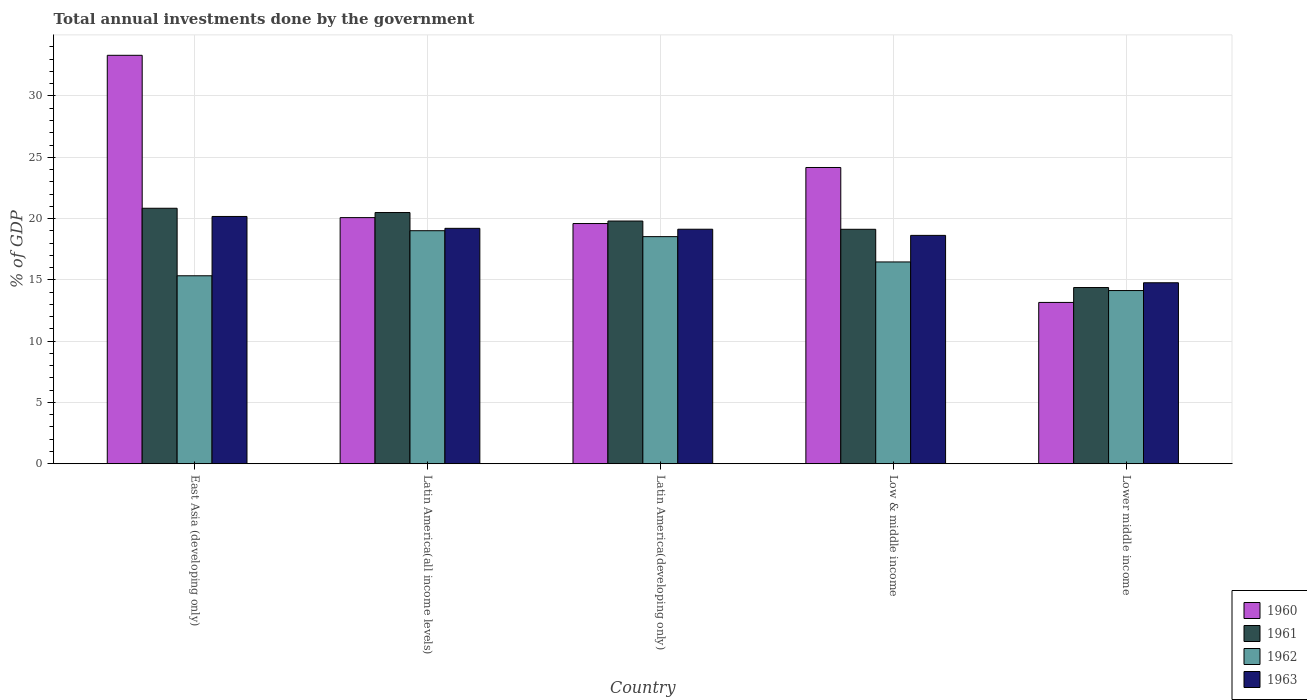Are the number of bars per tick equal to the number of legend labels?
Offer a very short reply. Yes. Are the number of bars on each tick of the X-axis equal?
Your response must be concise. Yes. How many bars are there on the 5th tick from the right?
Offer a terse response. 4. What is the label of the 2nd group of bars from the left?
Offer a terse response. Latin America(all income levels). What is the total annual investments done by the government in 1962 in Low & middle income?
Your answer should be compact. 16.46. Across all countries, what is the maximum total annual investments done by the government in 1961?
Make the answer very short. 20.84. Across all countries, what is the minimum total annual investments done by the government in 1962?
Give a very brief answer. 14.13. In which country was the total annual investments done by the government in 1963 maximum?
Provide a succinct answer. East Asia (developing only). In which country was the total annual investments done by the government in 1962 minimum?
Your answer should be very brief. Lower middle income. What is the total total annual investments done by the government in 1960 in the graph?
Your response must be concise. 110.32. What is the difference between the total annual investments done by the government in 1962 in Latin America(all income levels) and that in Latin America(developing only)?
Give a very brief answer. 0.48. What is the difference between the total annual investments done by the government in 1962 in Low & middle income and the total annual investments done by the government in 1963 in East Asia (developing only)?
Your answer should be compact. -3.71. What is the average total annual investments done by the government in 1963 per country?
Offer a terse response. 18.38. What is the difference between the total annual investments done by the government of/in 1962 and total annual investments done by the government of/in 1961 in Lower middle income?
Provide a succinct answer. -0.25. What is the ratio of the total annual investments done by the government in 1961 in Latin America(all income levels) to that in Lower middle income?
Keep it short and to the point. 1.43. Is the total annual investments done by the government in 1961 in East Asia (developing only) less than that in Latin America(all income levels)?
Provide a succinct answer. No. Is the difference between the total annual investments done by the government in 1962 in Latin America(developing only) and Lower middle income greater than the difference between the total annual investments done by the government in 1961 in Latin America(developing only) and Lower middle income?
Your answer should be compact. No. What is the difference between the highest and the second highest total annual investments done by the government in 1962?
Provide a short and direct response. -2.07. What is the difference between the highest and the lowest total annual investments done by the government in 1963?
Your answer should be very brief. 5.41. Is the sum of the total annual investments done by the government in 1961 in East Asia (developing only) and Lower middle income greater than the maximum total annual investments done by the government in 1960 across all countries?
Provide a succinct answer. Yes. Is it the case that in every country, the sum of the total annual investments done by the government in 1960 and total annual investments done by the government in 1961 is greater than the sum of total annual investments done by the government in 1963 and total annual investments done by the government in 1962?
Provide a short and direct response. No. What does the 4th bar from the left in Latin America(all income levels) represents?
Ensure brevity in your answer.  1963. How many bars are there?
Give a very brief answer. 20. Are all the bars in the graph horizontal?
Offer a very short reply. No. How many countries are there in the graph?
Offer a terse response. 5. Are the values on the major ticks of Y-axis written in scientific E-notation?
Ensure brevity in your answer.  No. What is the title of the graph?
Make the answer very short. Total annual investments done by the government. What is the label or title of the X-axis?
Offer a very short reply. Country. What is the label or title of the Y-axis?
Your answer should be very brief. % of GDP. What is the % of GDP of 1960 in East Asia (developing only)?
Offer a terse response. 33.32. What is the % of GDP in 1961 in East Asia (developing only)?
Your answer should be compact. 20.84. What is the % of GDP in 1962 in East Asia (developing only)?
Your answer should be compact. 15.33. What is the % of GDP of 1963 in East Asia (developing only)?
Keep it short and to the point. 20.17. What is the % of GDP in 1960 in Latin America(all income levels)?
Your response must be concise. 20.08. What is the % of GDP in 1961 in Latin America(all income levels)?
Give a very brief answer. 20.49. What is the % of GDP of 1962 in Latin America(all income levels)?
Provide a succinct answer. 19.01. What is the % of GDP of 1963 in Latin America(all income levels)?
Provide a short and direct response. 19.2. What is the % of GDP of 1960 in Latin America(developing only)?
Provide a succinct answer. 19.6. What is the % of GDP in 1961 in Latin America(developing only)?
Provide a succinct answer. 19.8. What is the % of GDP in 1962 in Latin America(developing only)?
Offer a very short reply. 18.53. What is the % of GDP in 1963 in Latin America(developing only)?
Your answer should be compact. 19.13. What is the % of GDP in 1960 in Low & middle income?
Offer a terse response. 24.17. What is the % of GDP of 1961 in Low & middle income?
Make the answer very short. 19.13. What is the % of GDP of 1962 in Low & middle income?
Provide a short and direct response. 16.46. What is the % of GDP in 1963 in Low & middle income?
Your answer should be very brief. 18.63. What is the % of GDP in 1960 in Lower middle income?
Offer a terse response. 13.16. What is the % of GDP of 1961 in Lower middle income?
Your response must be concise. 14.37. What is the % of GDP in 1962 in Lower middle income?
Provide a short and direct response. 14.13. What is the % of GDP of 1963 in Lower middle income?
Your answer should be very brief. 14.76. Across all countries, what is the maximum % of GDP in 1960?
Make the answer very short. 33.32. Across all countries, what is the maximum % of GDP of 1961?
Offer a terse response. 20.84. Across all countries, what is the maximum % of GDP of 1962?
Offer a very short reply. 19.01. Across all countries, what is the maximum % of GDP in 1963?
Ensure brevity in your answer.  20.17. Across all countries, what is the minimum % of GDP in 1960?
Provide a succinct answer. 13.16. Across all countries, what is the minimum % of GDP in 1961?
Keep it short and to the point. 14.37. Across all countries, what is the minimum % of GDP of 1962?
Give a very brief answer. 14.13. Across all countries, what is the minimum % of GDP in 1963?
Ensure brevity in your answer.  14.76. What is the total % of GDP of 1960 in the graph?
Your answer should be compact. 110.32. What is the total % of GDP of 1961 in the graph?
Ensure brevity in your answer.  94.63. What is the total % of GDP of 1962 in the graph?
Offer a terse response. 83.46. What is the total % of GDP in 1963 in the graph?
Ensure brevity in your answer.  91.9. What is the difference between the % of GDP in 1960 in East Asia (developing only) and that in Latin America(all income levels)?
Make the answer very short. 13.24. What is the difference between the % of GDP in 1961 in East Asia (developing only) and that in Latin America(all income levels)?
Keep it short and to the point. 0.35. What is the difference between the % of GDP of 1962 in East Asia (developing only) and that in Latin America(all income levels)?
Provide a short and direct response. -3.68. What is the difference between the % of GDP in 1963 in East Asia (developing only) and that in Latin America(all income levels)?
Your response must be concise. 0.97. What is the difference between the % of GDP of 1960 in East Asia (developing only) and that in Latin America(developing only)?
Ensure brevity in your answer.  13.72. What is the difference between the % of GDP of 1961 in East Asia (developing only) and that in Latin America(developing only)?
Keep it short and to the point. 1.04. What is the difference between the % of GDP of 1962 in East Asia (developing only) and that in Latin America(developing only)?
Make the answer very short. -3.19. What is the difference between the % of GDP in 1963 in East Asia (developing only) and that in Latin America(developing only)?
Ensure brevity in your answer.  1.04. What is the difference between the % of GDP of 1960 in East Asia (developing only) and that in Low & middle income?
Provide a succinct answer. 9.15. What is the difference between the % of GDP of 1961 in East Asia (developing only) and that in Low & middle income?
Your answer should be very brief. 1.72. What is the difference between the % of GDP of 1962 in East Asia (developing only) and that in Low & middle income?
Your response must be concise. -1.13. What is the difference between the % of GDP in 1963 in East Asia (developing only) and that in Low & middle income?
Provide a short and direct response. 1.54. What is the difference between the % of GDP of 1960 in East Asia (developing only) and that in Lower middle income?
Your response must be concise. 20.16. What is the difference between the % of GDP in 1961 in East Asia (developing only) and that in Lower middle income?
Offer a terse response. 6.47. What is the difference between the % of GDP in 1962 in East Asia (developing only) and that in Lower middle income?
Ensure brevity in your answer.  1.21. What is the difference between the % of GDP of 1963 in East Asia (developing only) and that in Lower middle income?
Make the answer very short. 5.41. What is the difference between the % of GDP in 1960 in Latin America(all income levels) and that in Latin America(developing only)?
Your answer should be compact. 0.48. What is the difference between the % of GDP in 1961 in Latin America(all income levels) and that in Latin America(developing only)?
Offer a terse response. 0.69. What is the difference between the % of GDP of 1962 in Latin America(all income levels) and that in Latin America(developing only)?
Keep it short and to the point. 0.48. What is the difference between the % of GDP of 1963 in Latin America(all income levels) and that in Latin America(developing only)?
Your answer should be compact. 0.07. What is the difference between the % of GDP in 1960 in Latin America(all income levels) and that in Low & middle income?
Offer a terse response. -4.09. What is the difference between the % of GDP of 1961 in Latin America(all income levels) and that in Low & middle income?
Make the answer very short. 1.37. What is the difference between the % of GDP of 1962 in Latin America(all income levels) and that in Low & middle income?
Make the answer very short. 2.55. What is the difference between the % of GDP of 1963 in Latin America(all income levels) and that in Low & middle income?
Your response must be concise. 0.57. What is the difference between the % of GDP in 1960 in Latin America(all income levels) and that in Lower middle income?
Make the answer very short. 6.92. What is the difference between the % of GDP in 1961 in Latin America(all income levels) and that in Lower middle income?
Offer a terse response. 6.12. What is the difference between the % of GDP in 1962 in Latin America(all income levels) and that in Lower middle income?
Your response must be concise. 4.88. What is the difference between the % of GDP in 1963 in Latin America(all income levels) and that in Lower middle income?
Your answer should be compact. 4.44. What is the difference between the % of GDP of 1960 in Latin America(developing only) and that in Low & middle income?
Keep it short and to the point. -4.57. What is the difference between the % of GDP of 1961 in Latin America(developing only) and that in Low & middle income?
Keep it short and to the point. 0.67. What is the difference between the % of GDP in 1962 in Latin America(developing only) and that in Low & middle income?
Make the answer very short. 2.07. What is the difference between the % of GDP of 1963 in Latin America(developing only) and that in Low & middle income?
Offer a terse response. 0.5. What is the difference between the % of GDP of 1960 in Latin America(developing only) and that in Lower middle income?
Keep it short and to the point. 6.44. What is the difference between the % of GDP of 1961 in Latin America(developing only) and that in Lower middle income?
Provide a short and direct response. 5.42. What is the difference between the % of GDP in 1962 in Latin America(developing only) and that in Lower middle income?
Your response must be concise. 4.4. What is the difference between the % of GDP in 1963 in Latin America(developing only) and that in Lower middle income?
Your answer should be very brief. 4.37. What is the difference between the % of GDP in 1960 in Low & middle income and that in Lower middle income?
Your answer should be very brief. 11.01. What is the difference between the % of GDP in 1961 in Low & middle income and that in Lower middle income?
Your answer should be very brief. 4.75. What is the difference between the % of GDP of 1962 in Low & middle income and that in Lower middle income?
Your answer should be very brief. 2.33. What is the difference between the % of GDP of 1963 in Low & middle income and that in Lower middle income?
Your response must be concise. 3.87. What is the difference between the % of GDP of 1960 in East Asia (developing only) and the % of GDP of 1961 in Latin America(all income levels)?
Provide a short and direct response. 12.83. What is the difference between the % of GDP of 1960 in East Asia (developing only) and the % of GDP of 1962 in Latin America(all income levels)?
Provide a succinct answer. 14.31. What is the difference between the % of GDP of 1960 in East Asia (developing only) and the % of GDP of 1963 in Latin America(all income levels)?
Ensure brevity in your answer.  14.12. What is the difference between the % of GDP in 1961 in East Asia (developing only) and the % of GDP in 1962 in Latin America(all income levels)?
Offer a very short reply. 1.83. What is the difference between the % of GDP of 1961 in East Asia (developing only) and the % of GDP of 1963 in Latin America(all income levels)?
Ensure brevity in your answer.  1.64. What is the difference between the % of GDP of 1962 in East Asia (developing only) and the % of GDP of 1963 in Latin America(all income levels)?
Your answer should be very brief. -3.87. What is the difference between the % of GDP of 1960 in East Asia (developing only) and the % of GDP of 1961 in Latin America(developing only)?
Offer a terse response. 13.52. What is the difference between the % of GDP in 1960 in East Asia (developing only) and the % of GDP in 1962 in Latin America(developing only)?
Make the answer very short. 14.79. What is the difference between the % of GDP in 1960 in East Asia (developing only) and the % of GDP in 1963 in Latin America(developing only)?
Provide a succinct answer. 14.19. What is the difference between the % of GDP of 1961 in East Asia (developing only) and the % of GDP of 1962 in Latin America(developing only)?
Give a very brief answer. 2.31. What is the difference between the % of GDP of 1961 in East Asia (developing only) and the % of GDP of 1963 in Latin America(developing only)?
Your response must be concise. 1.71. What is the difference between the % of GDP in 1962 in East Asia (developing only) and the % of GDP in 1963 in Latin America(developing only)?
Your answer should be very brief. -3.8. What is the difference between the % of GDP of 1960 in East Asia (developing only) and the % of GDP of 1961 in Low & middle income?
Make the answer very short. 14.19. What is the difference between the % of GDP in 1960 in East Asia (developing only) and the % of GDP in 1962 in Low & middle income?
Offer a terse response. 16.86. What is the difference between the % of GDP in 1960 in East Asia (developing only) and the % of GDP in 1963 in Low & middle income?
Offer a terse response. 14.69. What is the difference between the % of GDP in 1961 in East Asia (developing only) and the % of GDP in 1962 in Low & middle income?
Offer a terse response. 4.38. What is the difference between the % of GDP of 1961 in East Asia (developing only) and the % of GDP of 1963 in Low & middle income?
Your answer should be compact. 2.21. What is the difference between the % of GDP in 1962 in East Asia (developing only) and the % of GDP in 1963 in Low & middle income?
Your response must be concise. -3.3. What is the difference between the % of GDP of 1960 in East Asia (developing only) and the % of GDP of 1961 in Lower middle income?
Your answer should be compact. 18.95. What is the difference between the % of GDP of 1960 in East Asia (developing only) and the % of GDP of 1962 in Lower middle income?
Your answer should be very brief. 19.19. What is the difference between the % of GDP in 1960 in East Asia (developing only) and the % of GDP in 1963 in Lower middle income?
Provide a succinct answer. 18.56. What is the difference between the % of GDP in 1961 in East Asia (developing only) and the % of GDP in 1962 in Lower middle income?
Your answer should be compact. 6.71. What is the difference between the % of GDP in 1961 in East Asia (developing only) and the % of GDP in 1963 in Lower middle income?
Keep it short and to the point. 6.08. What is the difference between the % of GDP of 1962 in East Asia (developing only) and the % of GDP of 1963 in Lower middle income?
Provide a short and direct response. 0.57. What is the difference between the % of GDP of 1960 in Latin America(all income levels) and the % of GDP of 1961 in Latin America(developing only)?
Your answer should be very brief. 0.28. What is the difference between the % of GDP of 1960 in Latin America(all income levels) and the % of GDP of 1962 in Latin America(developing only)?
Your response must be concise. 1.55. What is the difference between the % of GDP in 1960 in Latin America(all income levels) and the % of GDP in 1963 in Latin America(developing only)?
Your answer should be very brief. 0.95. What is the difference between the % of GDP of 1961 in Latin America(all income levels) and the % of GDP of 1962 in Latin America(developing only)?
Provide a succinct answer. 1.97. What is the difference between the % of GDP in 1961 in Latin America(all income levels) and the % of GDP in 1963 in Latin America(developing only)?
Your response must be concise. 1.36. What is the difference between the % of GDP in 1962 in Latin America(all income levels) and the % of GDP in 1963 in Latin America(developing only)?
Provide a succinct answer. -0.12. What is the difference between the % of GDP of 1960 in Latin America(all income levels) and the % of GDP of 1961 in Low & middle income?
Your answer should be compact. 0.95. What is the difference between the % of GDP in 1960 in Latin America(all income levels) and the % of GDP in 1962 in Low & middle income?
Keep it short and to the point. 3.62. What is the difference between the % of GDP of 1960 in Latin America(all income levels) and the % of GDP of 1963 in Low & middle income?
Your answer should be very brief. 1.45. What is the difference between the % of GDP in 1961 in Latin America(all income levels) and the % of GDP in 1962 in Low & middle income?
Your response must be concise. 4.03. What is the difference between the % of GDP in 1961 in Latin America(all income levels) and the % of GDP in 1963 in Low & middle income?
Provide a short and direct response. 1.86. What is the difference between the % of GDP in 1962 in Latin America(all income levels) and the % of GDP in 1963 in Low & middle income?
Provide a succinct answer. 0.38. What is the difference between the % of GDP in 1960 in Latin America(all income levels) and the % of GDP in 1961 in Lower middle income?
Provide a succinct answer. 5.7. What is the difference between the % of GDP of 1960 in Latin America(all income levels) and the % of GDP of 1962 in Lower middle income?
Your answer should be compact. 5.95. What is the difference between the % of GDP in 1960 in Latin America(all income levels) and the % of GDP in 1963 in Lower middle income?
Your answer should be compact. 5.31. What is the difference between the % of GDP of 1961 in Latin America(all income levels) and the % of GDP of 1962 in Lower middle income?
Your response must be concise. 6.36. What is the difference between the % of GDP of 1961 in Latin America(all income levels) and the % of GDP of 1963 in Lower middle income?
Make the answer very short. 5.73. What is the difference between the % of GDP in 1962 in Latin America(all income levels) and the % of GDP in 1963 in Lower middle income?
Give a very brief answer. 4.25. What is the difference between the % of GDP in 1960 in Latin America(developing only) and the % of GDP in 1961 in Low & middle income?
Give a very brief answer. 0.47. What is the difference between the % of GDP in 1960 in Latin America(developing only) and the % of GDP in 1962 in Low & middle income?
Offer a very short reply. 3.13. What is the difference between the % of GDP in 1960 in Latin America(developing only) and the % of GDP in 1963 in Low & middle income?
Ensure brevity in your answer.  0.97. What is the difference between the % of GDP in 1961 in Latin America(developing only) and the % of GDP in 1962 in Low & middle income?
Provide a succinct answer. 3.34. What is the difference between the % of GDP of 1961 in Latin America(developing only) and the % of GDP of 1963 in Low & middle income?
Offer a very short reply. 1.17. What is the difference between the % of GDP in 1962 in Latin America(developing only) and the % of GDP in 1963 in Low & middle income?
Your answer should be very brief. -0.1. What is the difference between the % of GDP in 1960 in Latin America(developing only) and the % of GDP in 1961 in Lower middle income?
Make the answer very short. 5.22. What is the difference between the % of GDP in 1960 in Latin America(developing only) and the % of GDP in 1962 in Lower middle income?
Offer a terse response. 5.47. What is the difference between the % of GDP in 1960 in Latin America(developing only) and the % of GDP in 1963 in Lower middle income?
Your answer should be compact. 4.83. What is the difference between the % of GDP in 1961 in Latin America(developing only) and the % of GDP in 1962 in Lower middle income?
Your response must be concise. 5.67. What is the difference between the % of GDP in 1961 in Latin America(developing only) and the % of GDP in 1963 in Lower middle income?
Ensure brevity in your answer.  5.04. What is the difference between the % of GDP of 1962 in Latin America(developing only) and the % of GDP of 1963 in Lower middle income?
Give a very brief answer. 3.76. What is the difference between the % of GDP in 1960 in Low & middle income and the % of GDP in 1961 in Lower middle income?
Provide a short and direct response. 9.79. What is the difference between the % of GDP of 1960 in Low & middle income and the % of GDP of 1962 in Lower middle income?
Your answer should be very brief. 10.04. What is the difference between the % of GDP of 1960 in Low & middle income and the % of GDP of 1963 in Lower middle income?
Your answer should be compact. 9.4. What is the difference between the % of GDP in 1961 in Low & middle income and the % of GDP in 1962 in Lower middle income?
Offer a very short reply. 5. What is the difference between the % of GDP of 1961 in Low & middle income and the % of GDP of 1963 in Lower middle income?
Offer a terse response. 4.36. What is the difference between the % of GDP of 1962 in Low & middle income and the % of GDP of 1963 in Lower middle income?
Provide a succinct answer. 1.7. What is the average % of GDP of 1960 per country?
Give a very brief answer. 22.06. What is the average % of GDP in 1961 per country?
Provide a succinct answer. 18.93. What is the average % of GDP in 1962 per country?
Offer a very short reply. 16.69. What is the average % of GDP in 1963 per country?
Your answer should be very brief. 18.38. What is the difference between the % of GDP of 1960 and % of GDP of 1961 in East Asia (developing only)?
Provide a short and direct response. 12.48. What is the difference between the % of GDP in 1960 and % of GDP in 1962 in East Asia (developing only)?
Give a very brief answer. 17.99. What is the difference between the % of GDP in 1960 and % of GDP in 1963 in East Asia (developing only)?
Offer a very short reply. 13.15. What is the difference between the % of GDP in 1961 and % of GDP in 1962 in East Asia (developing only)?
Your response must be concise. 5.51. What is the difference between the % of GDP of 1961 and % of GDP of 1963 in East Asia (developing only)?
Ensure brevity in your answer.  0.67. What is the difference between the % of GDP in 1962 and % of GDP in 1963 in East Asia (developing only)?
Your response must be concise. -4.84. What is the difference between the % of GDP in 1960 and % of GDP in 1961 in Latin America(all income levels)?
Provide a succinct answer. -0.41. What is the difference between the % of GDP in 1960 and % of GDP in 1962 in Latin America(all income levels)?
Make the answer very short. 1.07. What is the difference between the % of GDP of 1960 and % of GDP of 1963 in Latin America(all income levels)?
Provide a succinct answer. 0.87. What is the difference between the % of GDP of 1961 and % of GDP of 1962 in Latin America(all income levels)?
Your response must be concise. 1.48. What is the difference between the % of GDP of 1961 and % of GDP of 1963 in Latin America(all income levels)?
Provide a short and direct response. 1.29. What is the difference between the % of GDP of 1962 and % of GDP of 1963 in Latin America(all income levels)?
Keep it short and to the point. -0.19. What is the difference between the % of GDP of 1960 and % of GDP of 1961 in Latin America(developing only)?
Ensure brevity in your answer.  -0.2. What is the difference between the % of GDP in 1960 and % of GDP in 1962 in Latin America(developing only)?
Your answer should be compact. 1.07. What is the difference between the % of GDP in 1960 and % of GDP in 1963 in Latin America(developing only)?
Give a very brief answer. 0.46. What is the difference between the % of GDP in 1961 and % of GDP in 1962 in Latin America(developing only)?
Provide a succinct answer. 1.27. What is the difference between the % of GDP of 1961 and % of GDP of 1963 in Latin America(developing only)?
Give a very brief answer. 0.67. What is the difference between the % of GDP in 1962 and % of GDP in 1963 in Latin America(developing only)?
Your answer should be compact. -0.6. What is the difference between the % of GDP of 1960 and % of GDP of 1961 in Low & middle income?
Keep it short and to the point. 5.04. What is the difference between the % of GDP in 1960 and % of GDP in 1962 in Low & middle income?
Your answer should be compact. 7.71. What is the difference between the % of GDP of 1960 and % of GDP of 1963 in Low & middle income?
Your response must be concise. 5.54. What is the difference between the % of GDP of 1961 and % of GDP of 1962 in Low & middle income?
Your answer should be compact. 2.67. What is the difference between the % of GDP in 1961 and % of GDP in 1963 in Low & middle income?
Offer a terse response. 0.5. What is the difference between the % of GDP of 1962 and % of GDP of 1963 in Low & middle income?
Provide a short and direct response. -2.17. What is the difference between the % of GDP of 1960 and % of GDP of 1961 in Lower middle income?
Offer a terse response. -1.22. What is the difference between the % of GDP in 1960 and % of GDP in 1962 in Lower middle income?
Your response must be concise. -0.97. What is the difference between the % of GDP of 1960 and % of GDP of 1963 in Lower middle income?
Provide a short and direct response. -1.6. What is the difference between the % of GDP of 1961 and % of GDP of 1962 in Lower middle income?
Provide a succinct answer. 0.25. What is the difference between the % of GDP in 1961 and % of GDP in 1963 in Lower middle income?
Offer a very short reply. -0.39. What is the difference between the % of GDP in 1962 and % of GDP in 1963 in Lower middle income?
Your answer should be compact. -0.64. What is the ratio of the % of GDP of 1960 in East Asia (developing only) to that in Latin America(all income levels)?
Your answer should be very brief. 1.66. What is the ratio of the % of GDP in 1962 in East Asia (developing only) to that in Latin America(all income levels)?
Keep it short and to the point. 0.81. What is the ratio of the % of GDP of 1963 in East Asia (developing only) to that in Latin America(all income levels)?
Give a very brief answer. 1.05. What is the ratio of the % of GDP in 1960 in East Asia (developing only) to that in Latin America(developing only)?
Provide a succinct answer. 1.7. What is the ratio of the % of GDP in 1961 in East Asia (developing only) to that in Latin America(developing only)?
Your answer should be very brief. 1.05. What is the ratio of the % of GDP in 1962 in East Asia (developing only) to that in Latin America(developing only)?
Provide a short and direct response. 0.83. What is the ratio of the % of GDP of 1963 in East Asia (developing only) to that in Latin America(developing only)?
Your answer should be very brief. 1.05. What is the ratio of the % of GDP in 1960 in East Asia (developing only) to that in Low & middle income?
Provide a short and direct response. 1.38. What is the ratio of the % of GDP in 1961 in East Asia (developing only) to that in Low & middle income?
Give a very brief answer. 1.09. What is the ratio of the % of GDP in 1962 in East Asia (developing only) to that in Low & middle income?
Keep it short and to the point. 0.93. What is the ratio of the % of GDP of 1963 in East Asia (developing only) to that in Low & middle income?
Your answer should be compact. 1.08. What is the ratio of the % of GDP in 1960 in East Asia (developing only) to that in Lower middle income?
Your answer should be compact. 2.53. What is the ratio of the % of GDP of 1961 in East Asia (developing only) to that in Lower middle income?
Keep it short and to the point. 1.45. What is the ratio of the % of GDP of 1962 in East Asia (developing only) to that in Lower middle income?
Keep it short and to the point. 1.09. What is the ratio of the % of GDP of 1963 in East Asia (developing only) to that in Lower middle income?
Your answer should be compact. 1.37. What is the ratio of the % of GDP of 1960 in Latin America(all income levels) to that in Latin America(developing only)?
Provide a succinct answer. 1.02. What is the ratio of the % of GDP in 1961 in Latin America(all income levels) to that in Latin America(developing only)?
Your response must be concise. 1.03. What is the ratio of the % of GDP in 1962 in Latin America(all income levels) to that in Latin America(developing only)?
Keep it short and to the point. 1.03. What is the ratio of the % of GDP in 1963 in Latin America(all income levels) to that in Latin America(developing only)?
Keep it short and to the point. 1. What is the ratio of the % of GDP in 1960 in Latin America(all income levels) to that in Low & middle income?
Give a very brief answer. 0.83. What is the ratio of the % of GDP in 1961 in Latin America(all income levels) to that in Low & middle income?
Your answer should be very brief. 1.07. What is the ratio of the % of GDP of 1962 in Latin America(all income levels) to that in Low & middle income?
Make the answer very short. 1.15. What is the ratio of the % of GDP of 1963 in Latin America(all income levels) to that in Low & middle income?
Make the answer very short. 1.03. What is the ratio of the % of GDP in 1960 in Latin America(all income levels) to that in Lower middle income?
Your answer should be very brief. 1.53. What is the ratio of the % of GDP in 1961 in Latin America(all income levels) to that in Lower middle income?
Your response must be concise. 1.43. What is the ratio of the % of GDP in 1962 in Latin America(all income levels) to that in Lower middle income?
Make the answer very short. 1.35. What is the ratio of the % of GDP in 1963 in Latin America(all income levels) to that in Lower middle income?
Offer a very short reply. 1.3. What is the ratio of the % of GDP in 1960 in Latin America(developing only) to that in Low & middle income?
Offer a very short reply. 0.81. What is the ratio of the % of GDP in 1961 in Latin America(developing only) to that in Low & middle income?
Offer a very short reply. 1.04. What is the ratio of the % of GDP in 1962 in Latin America(developing only) to that in Low & middle income?
Provide a succinct answer. 1.13. What is the ratio of the % of GDP in 1963 in Latin America(developing only) to that in Low & middle income?
Make the answer very short. 1.03. What is the ratio of the % of GDP of 1960 in Latin America(developing only) to that in Lower middle income?
Provide a short and direct response. 1.49. What is the ratio of the % of GDP in 1961 in Latin America(developing only) to that in Lower middle income?
Offer a very short reply. 1.38. What is the ratio of the % of GDP in 1962 in Latin America(developing only) to that in Lower middle income?
Your answer should be very brief. 1.31. What is the ratio of the % of GDP of 1963 in Latin America(developing only) to that in Lower middle income?
Keep it short and to the point. 1.3. What is the ratio of the % of GDP of 1960 in Low & middle income to that in Lower middle income?
Give a very brief answer. 1.84. What is the ratio of the % of GDP of 1961 in Low & middle income to that in Lower middle income?
Offer a very short reply. 1.33. What is the ratio of the % of GDP of 1962 in Low & middle income to that in Lower middle income?
Your answer should be very brief. 1.17. What is the ratio of the % of GDP in 1963 in Low & middle income to that in Lower middle income?
Your response must be concise. 1.26. What is the difference between the highest and the second highest % of GDP in 1960?
Keep it short and to the point. 9.15. What is the difference between the highest and the second highest % of GDP in 1961?
Your answer should be very brief. 0.35. What is the difference between the highest and the second highest % of GDP of 1962?
Provide a succinct answer. 0.48. What is the difference between the highest and the second highest % of GDP in 1963?
Ensure brevity in your answer.  0.97. What is the difference between the highest and the lowest % of GDP in 1960?
Give a very brief answer. 20.16. What is the difference between the highest and the lowest % of GDP in 1961?
Provide a succinct answer. 6.47. What is the difference between the highest and the lowest % of GDP in 1962?
Ensure brevity in your answer.  4.88. What is the difference between the highest and the lowest % of GDP of 1963?
Offer a terse response. 5.41. 